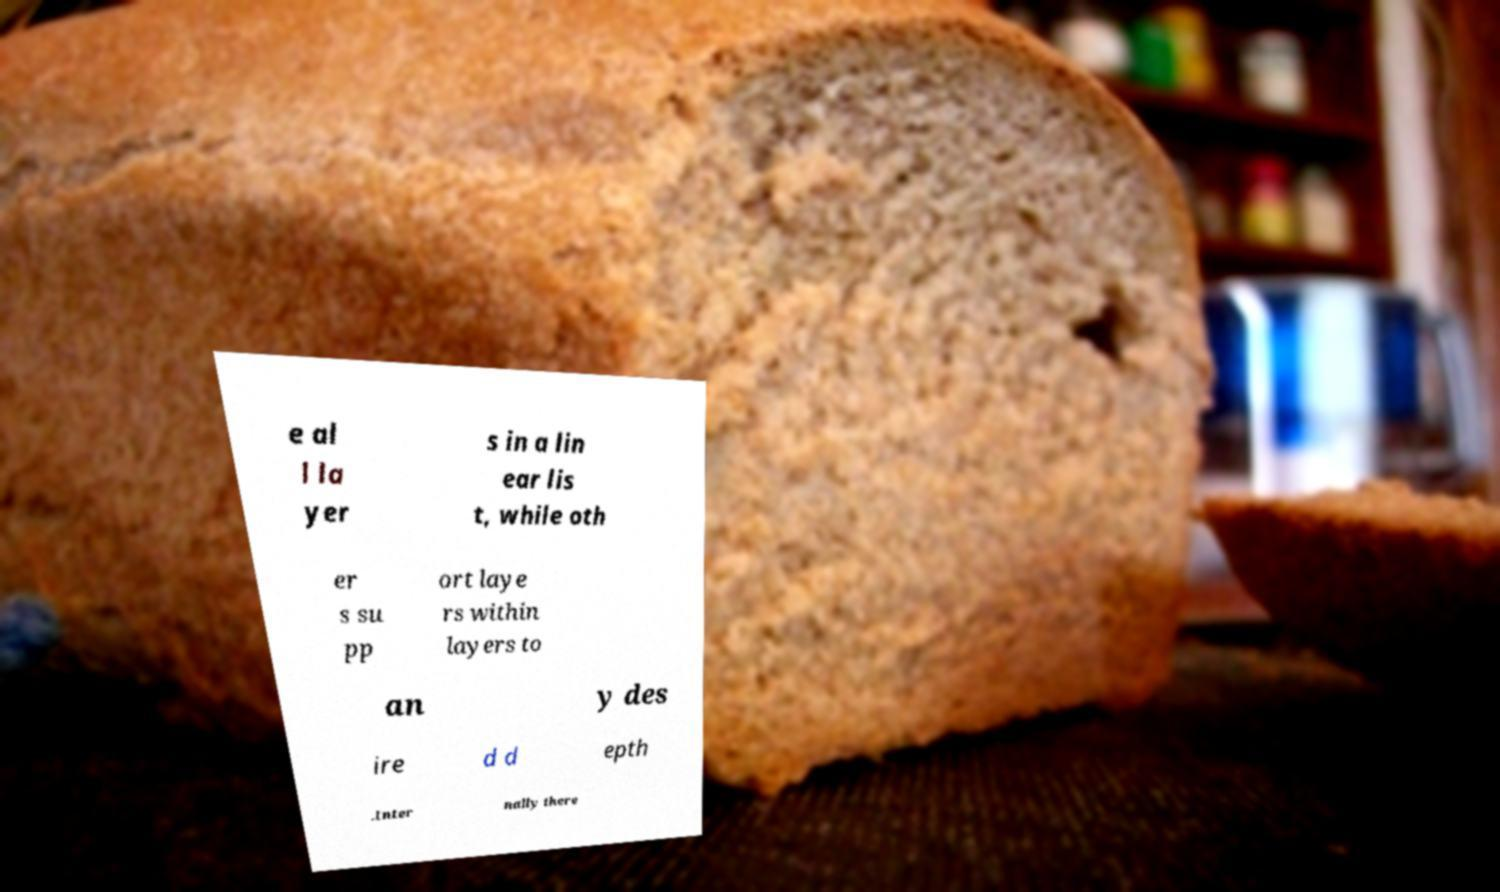For documentation purposes, I need the text within this image transcribed. Could you provide that? e al l la yer s in a lin ear lis t, while oth er s su pp ort laye rs within layers to an y des ire d d epth .Inter nally there 